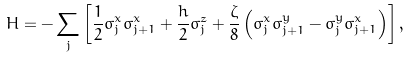Convert formula to latex. <formula><loc_0><loc_0><loc_500><loc_500>H = - \sum _ { j } \left [ \frac { 1 } { 2 } \sigma _ { j } ^ { x } \sigma _ { j + 1 } ^ { x } + \frac { h } { 2 } \sigma _ { j } ^ { z } + \frac { \zeta } { 8 } \left ( \sigma _ { j } ^ { x } \sigma _ { j + 1 } ^ { y } - \sigma _ { j } ^ { y } \sigma _ { j + 1 } ^ { x } \right ) \right ] ,</formula> 